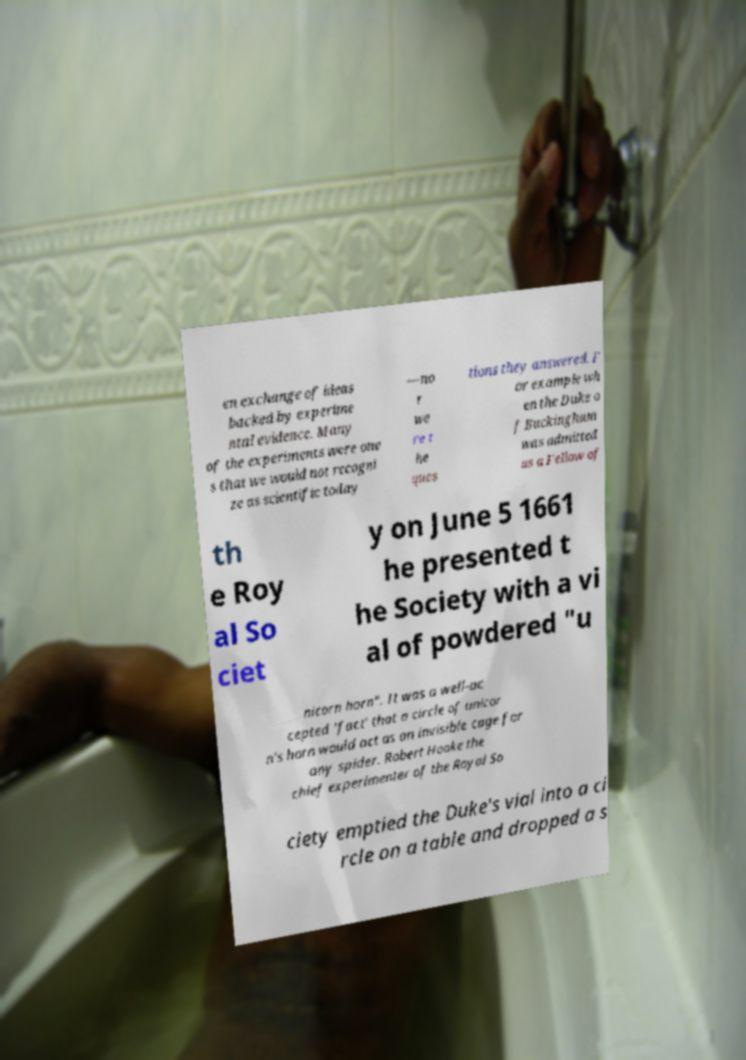I need the written content from this picture converted into text. Can you do that? en exchange of ideas backed by experime ntal evidence. Many of the experiments were one s that we would not recogni ze as scientific today —no r we re t he ques tions they answered. F or example wh en the Duke o f Buckingham was admitted as a Fellow of th e Roy al So ciet y on June 5 1661 he presented t he Society with a vi al of powdered "u nicorn horn". It was a well-ac cepted 'fact' that a circle of unicor n's horn would act as an invisible cage for any spider. Robert Hooke the chief experimenter of the Royal So ciety emptied the Duke's vial into a ci rcle on a table and dropped a s 